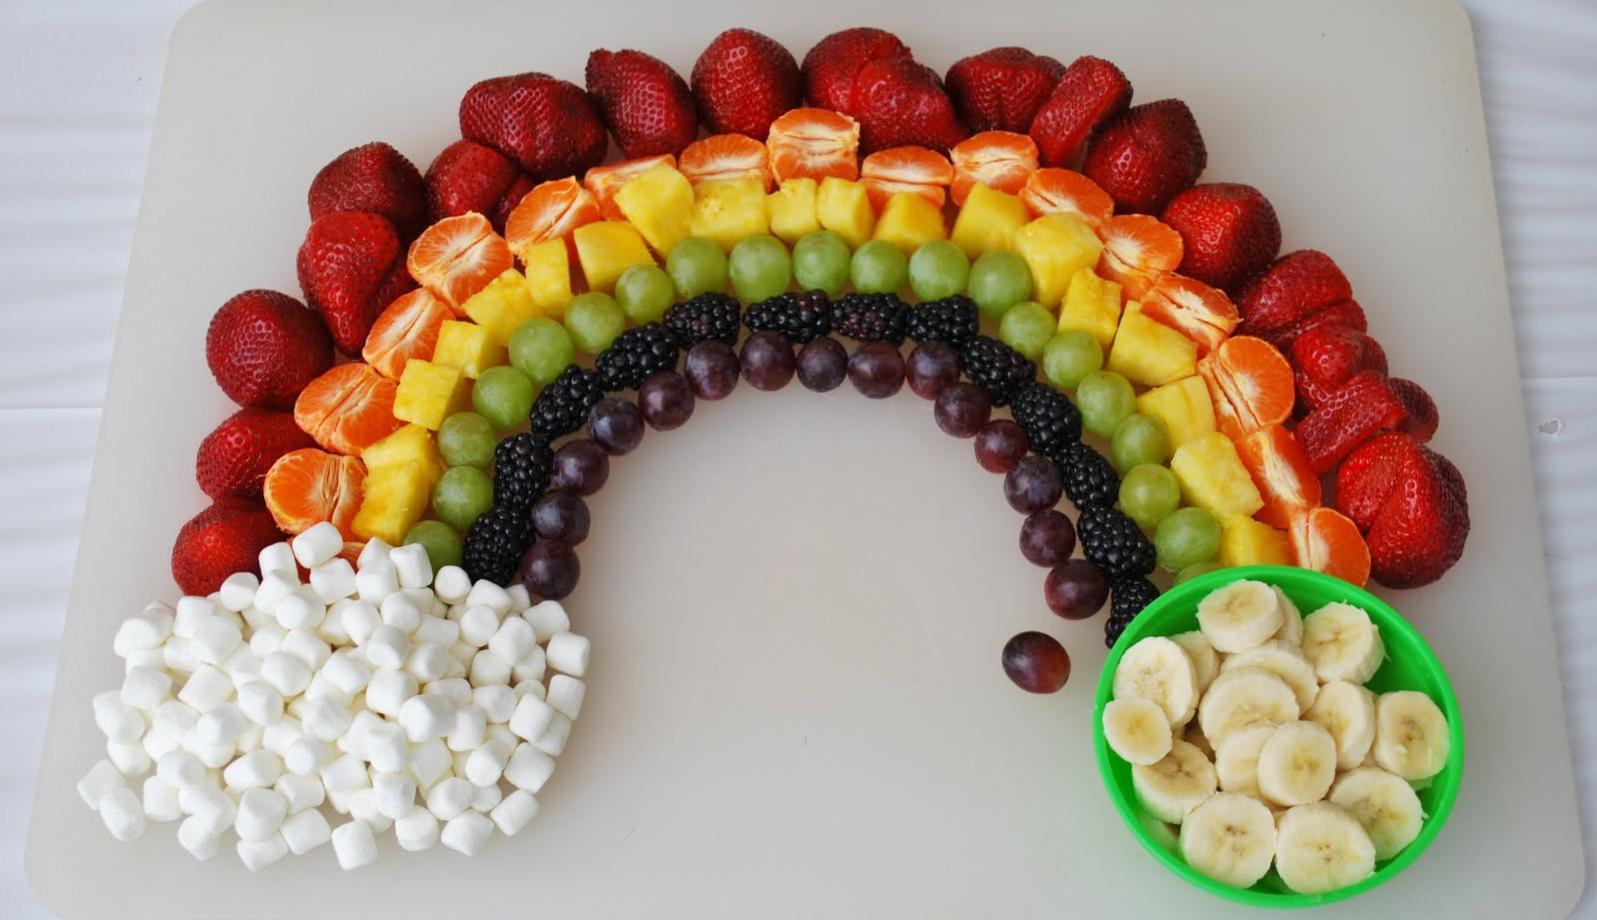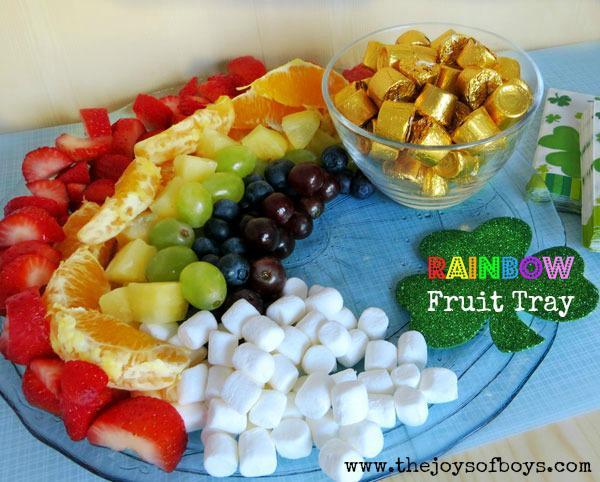The first image is the image on the left, the second image is the image on the right. For the images displayed, is the sentence "Right image shows fruit forming half-circle rainbow shape without use of spears." factually correct? Answer yes or no. Yes. 